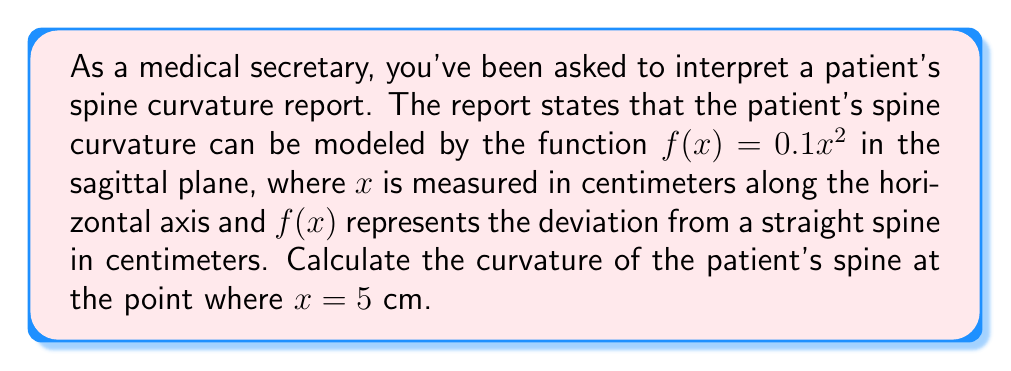Teach me how to tackle this problem. To calculate the curvature of the patient's spine, we'll use the formula for the curvature of a plane curve:

$$\kappa = \frac{|f''(x)|}{(1 + [f'(x)]^2)^{3/2}}$$

Step 1: Find $f'(x)$ and $f''(x)$
$f(x) = 0.1x^2$
$f'(x) = 0.2x$
$f''(x) = 0.2$

Step 2: Evaluate $f'(x)$ at $x = 5$
$f'(5) = 0.2 \cdot 5 = 1$

Step 3: Substitute values into the curvature formula
$$\kappa = \frac{|0.2|}{(1 + [1]^2)^{3/2}}$$

Step 4: Simplify
$$\kappa = \frac{0.2}{(1 + 1)^{3/2}} = \frac{0.2}{2^{3/2}} = \frac{0.2}{2\sqrt{2}}$$

Step 5: Calculate the final value
$$\kappa = \frac{0.1}{\sqrt{2}} \approx 0.0707 \text{ cm}^{-1}$$
Answer: $\frac{0.1}{\sqrt{2}} \approx 0.0707 \text{ cm}^{-1}$ 